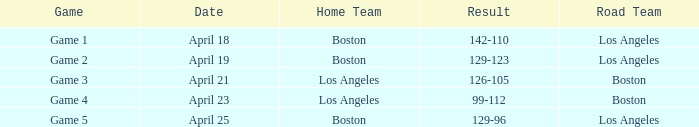WHAT IS THE DATE WITH BOSTON ROAD TEAM AND 126-105 RESULT? April 21. 